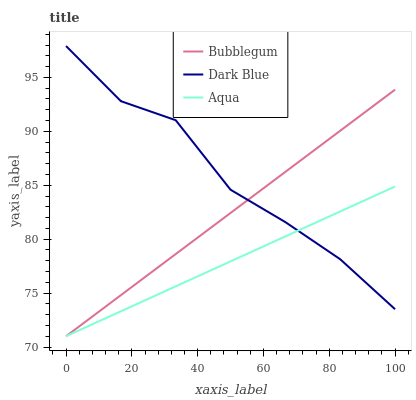Does Bubblegum have the minimum area under the curve?
Answer yes or no. No. Does Bubblegum have the maximum area under the curve?
Answer yes or no. No. Is Aqua the smoothest?
Answer yes or no. No. Is Aqua the roughest?
Answer yes or no. No. Does Bubblegum have the highest value?
Answer yes or no. No. 